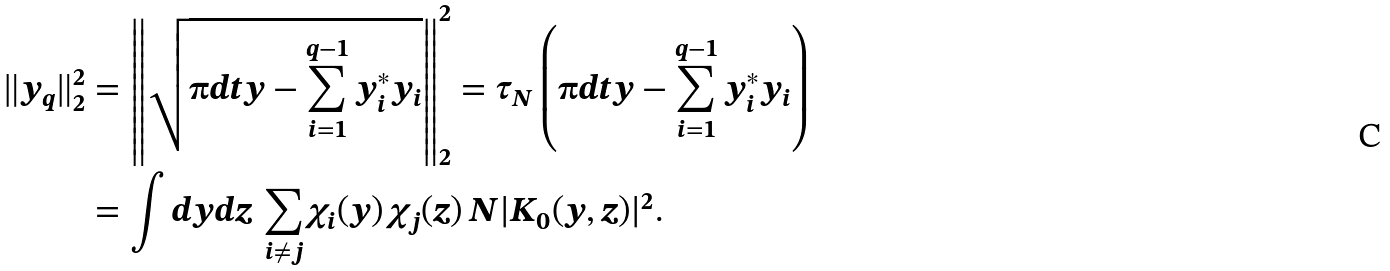<formula> <loc_0><loc_0><loc_500><loc_500>\| y _ { q } \| _ { 2 } ^ { 2 } & = \left \| \sqrt { \i d t y - \sum _ { i = 1 } ^ { q - 1 } y _ { i } ^ { * } y _ { i } } \right \| _ { 2 } ^ { 2 } = \tau _ { N } \left ( \i d t y - \sum _ { i = 1 } ^ { q - 1 } y _ { i } ^ { * } y _ { i } \right ) \\ & = \int d y d z \, \sum _ { i \ne j } \chi _ { i } ( y ) \, \chi _ { j } ( z ) \, N | K _ { 0 } ( y , z ) | ^ { 2 } .</formula> 